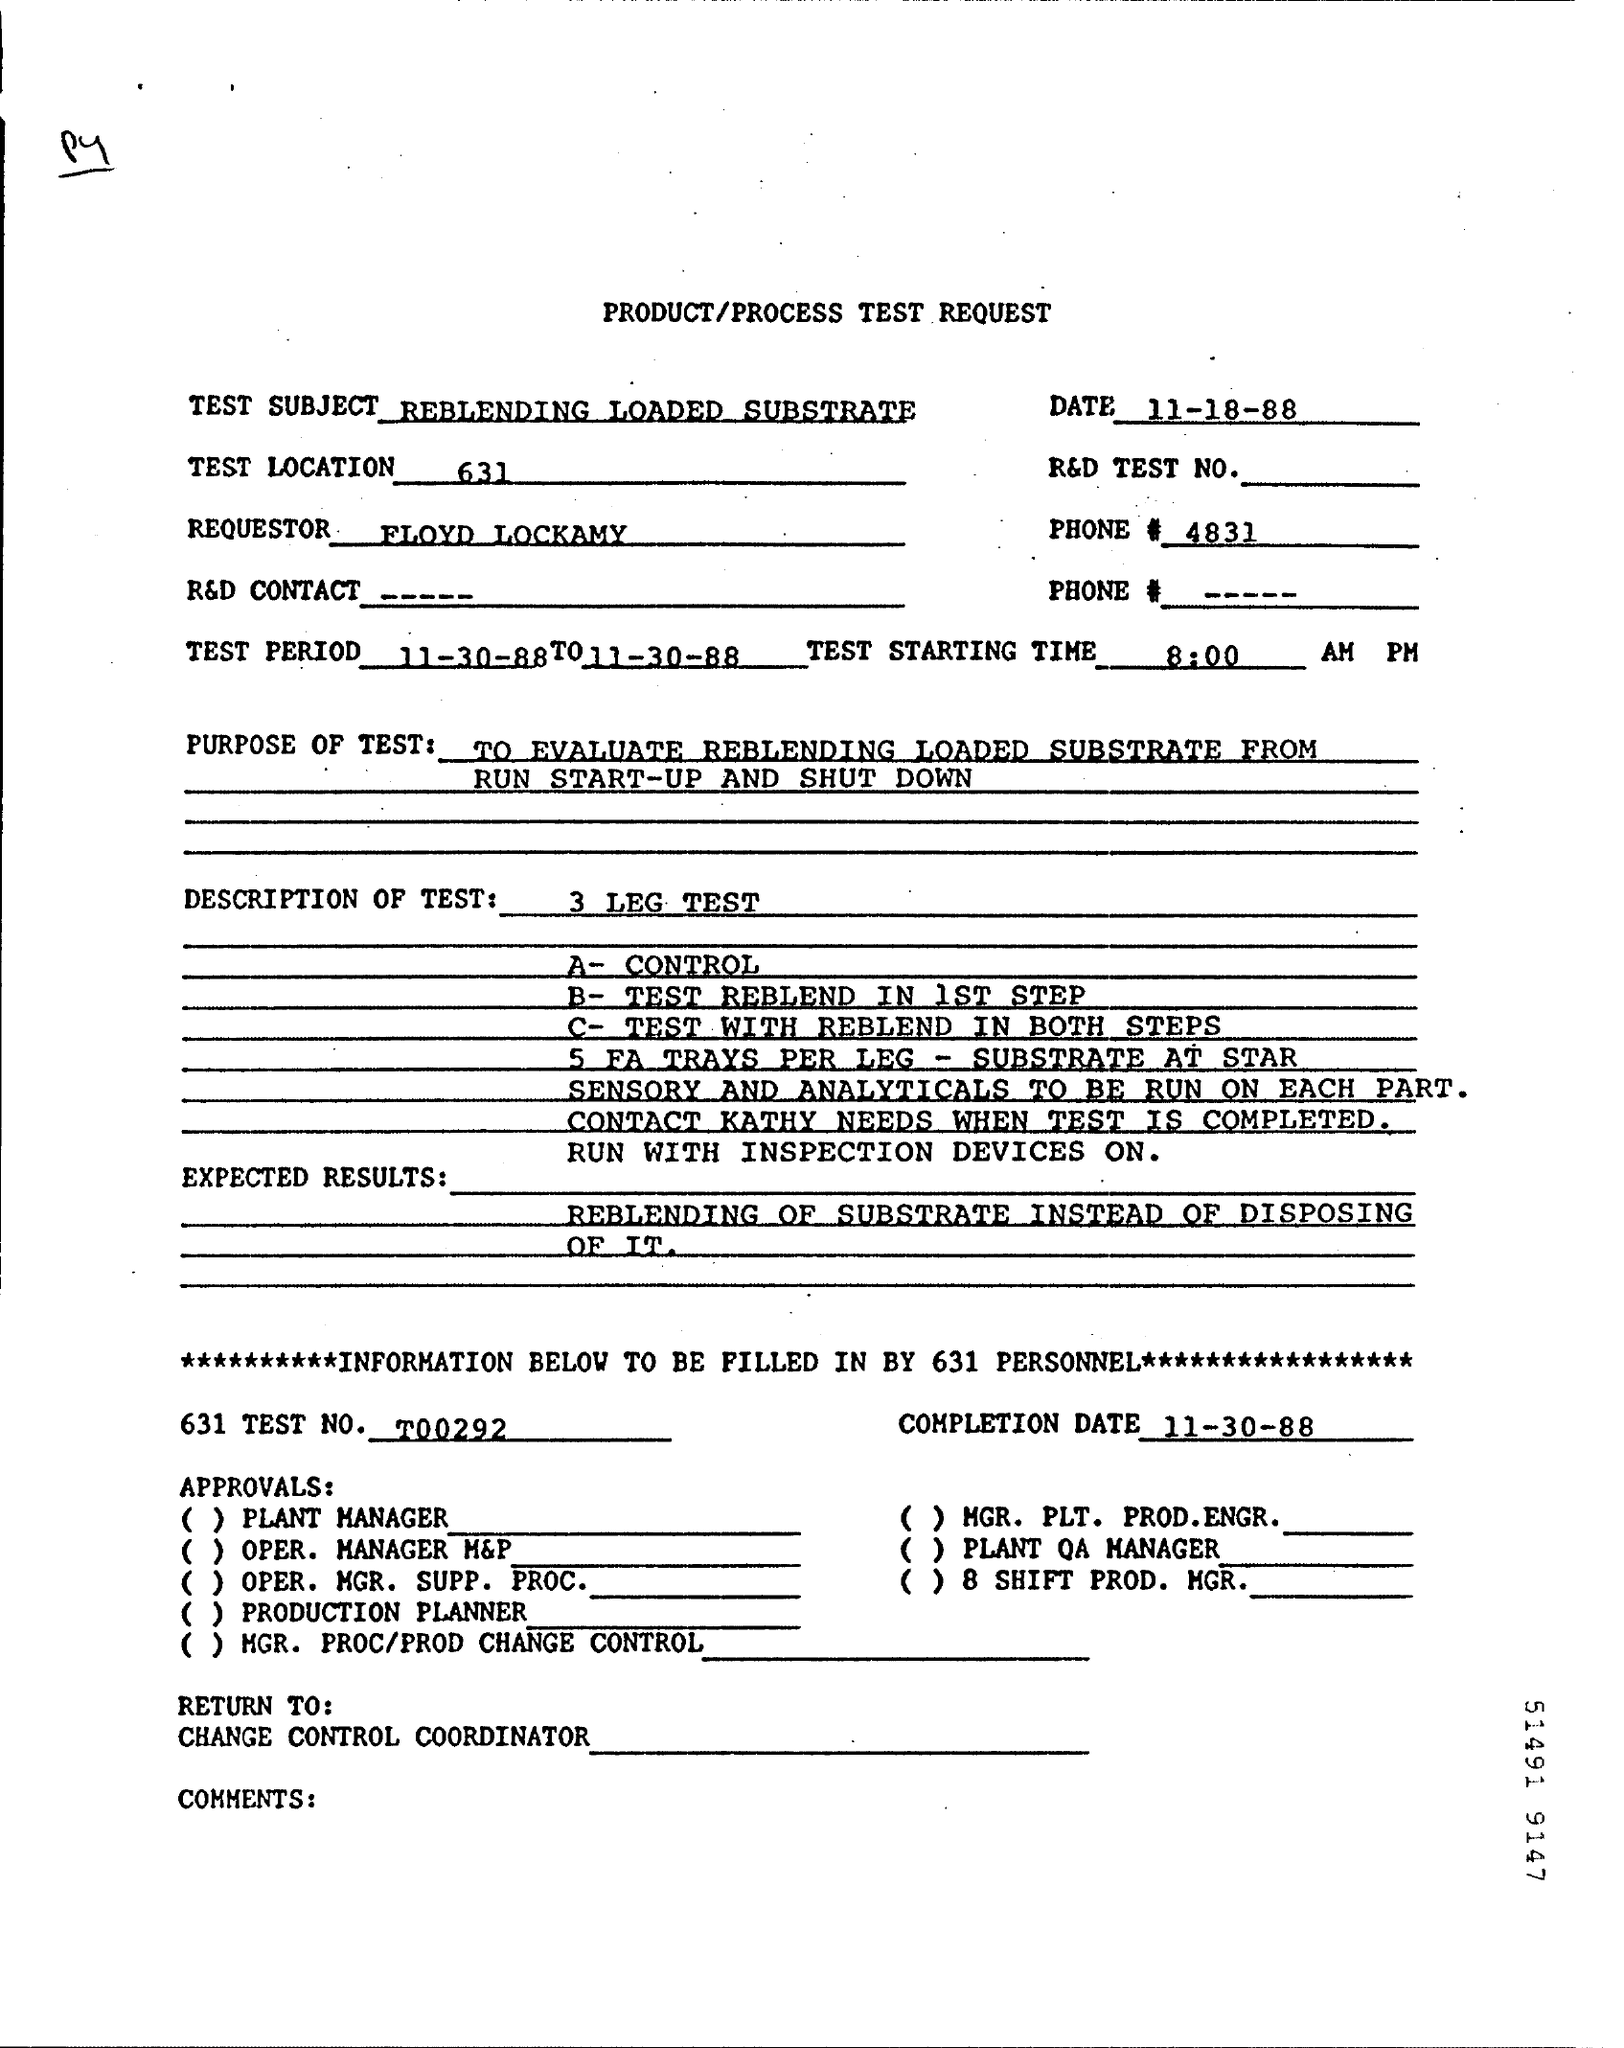List a handful of essential elements in this visual. The starting time for the test as specified in the form is 8:00 AM in Pacific Time. What is the test location, given 631? The subject of the test request is "REBLENDING LOADED SUBSTRATE. On what date was the requested test conducted? The person making the request is FLOYD LOCKAMY. 